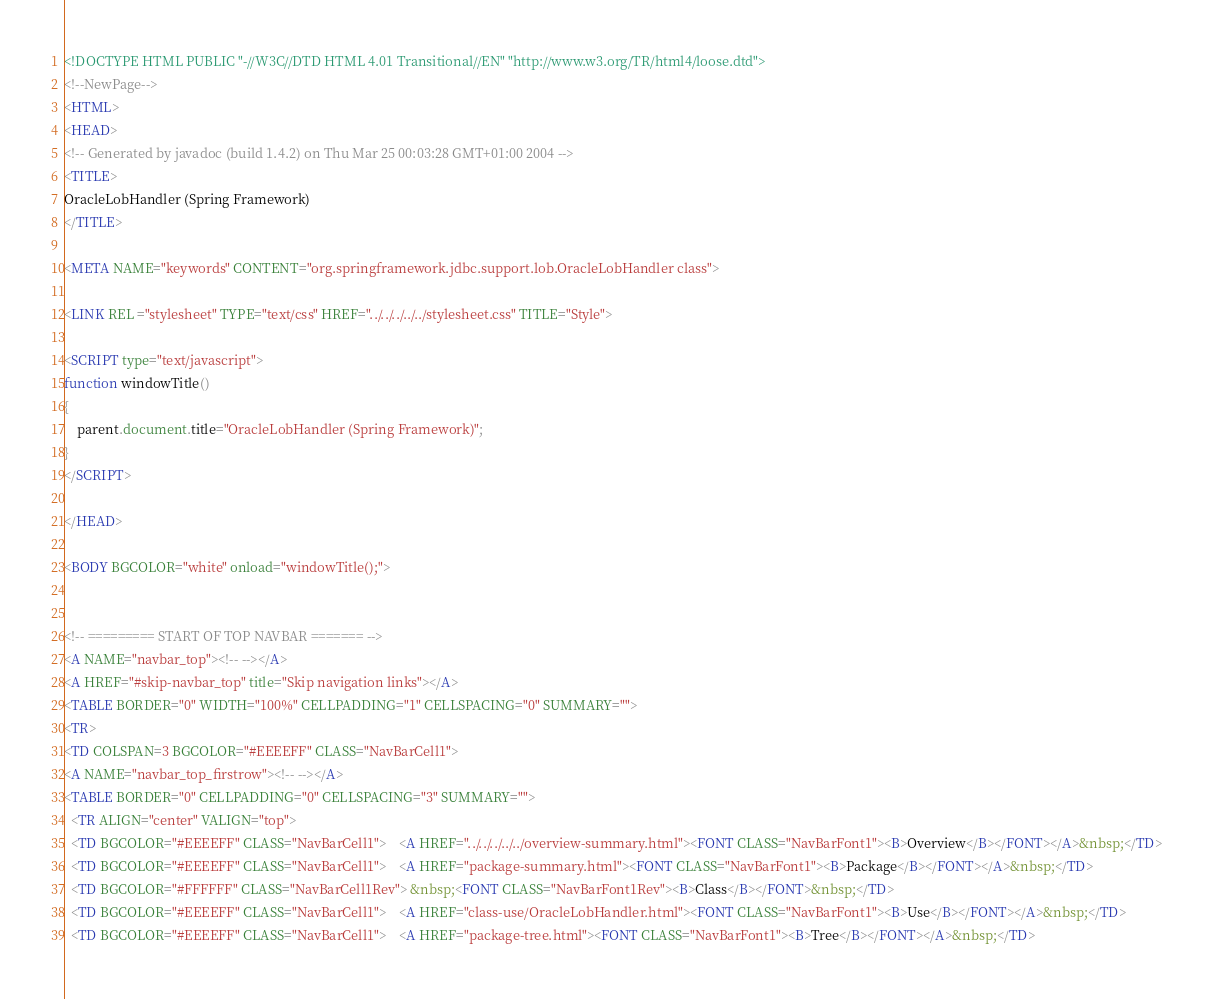Convert code to text. <code><loc_0><loc_0><loc_500><loc_500><_HTML_><!DOCTYPE HTML PUBLIC "-//W3C//DTD HTML 4.01 Transitional//EN" "http://www.w3.org/TR/html4/loose.dtd">
<!--NewPage-->
<HTML>
<HEAD>
<!-- Generated by javadoc (build 1.4.2) on Thu Mar 25 00:03:28 GMT+01:00 2004 -->
<TITLE>
OracleLobHandler (Spring Framework)
</TITLE>

<META NAME="keywords" CONTENT="org.springframework.jdbc.support.lob.OracleLobHandler class">

<LINK REL ="stylesheet" TYPE="text/css" HREF="../../../../../stylesheet.css" TITLE="Style">

<SCRIPT type="text/javascript">
function windowTitle()
{
    parent.document.title="OracleLobHandler (Spring Framework)";
}
</SCRIPT>

</HEAD>

<BODY BGCOLOR="white" onload="windowTitle();">


<!-- ========= START OF TOP NAVBAR ======= -->
<A NAME="navbar_top"><!-- --></A>
<A HREF="#skip-navbar_top" title="Skip navigation links"></A>
<TABLE BORDER="0" WIDTH="100%" CELLPADDING="1" CELLSPACING="0" SUMMARY="">
<TR>
<TD COLSPAN=3 BGCOLOR="#EEEEFF" CLASS="NavBarCell1">
<A NAME="navbar_top_firstrow"><!-- --></A>
<TABLE BORDER="0" CELLPADDING="0" CELLSPACING="3" SUMMARY="">
  <TR ALIGN="center" VALIGN="top">
  <TD BGCOLOR="#EEEEFF" CLASS="NavBarCell1">    <A HREF="../../../../../overview-summary.html"><FONT CLASS="NavBarFont1"><B>Overview</B></FONT></A>&nbsp;</TD>
  <TD BGCOLOR="#EEEEFF" CLASS="NavBarCell1">    <A HREF="package-summary.html"><FONT CLASS="NavBarFont1"><B>Package</B></FONT></A>&nbsp;</TD>
  <TD BGCOLOR="#FFFFFF" CLASS="NavBarCell1Rev"> &nbsp;<FONT CLASS="NavBarFont1Rev"><B>Class</B></FONT>&nbsp;</TD>
  <TD BGCOLOR="#EEEEFF" CLASS="NavBarCell1">    <A HREF="class-use/OracleLobHandler.html"><FONT CLASS="NavBarFont1"><B>Use</B></FONT></A>&nbsp;</TD>
  <TD BGCOLOR="#EEEEFF" CLASS="NavBarCell1">    <A HREF="package-tree.html"><FONT CLASS="NavBarFont1"><B>Tree</B></FONT></A>&nbsp;</TD></code> 